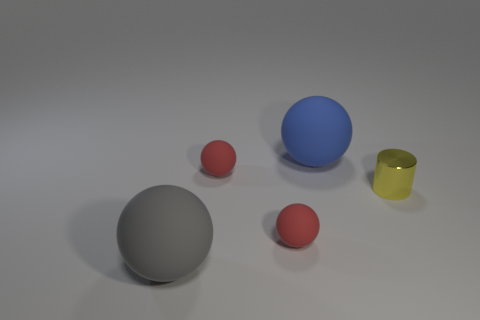Are there any other tiny yellow cylinders made of the same material as the cylinder?
Provide a succinct answer. No. The metallic cylinder has what size?
Your answer should be compact. Small. How many cyan things are either small rubber objects or shiny cylinders?
Give a very brief answer. 0. How many small red matte things have the same shape as the gray rubber thing?
Offer a terse response. 2. What number of matte objects have the same size as the yellow metallic cylinder?
Make the answer very short. 2. There is another big object that is the same shape as the large blue object; what is it made of?
Provide a succinct answer. Rubber. There is a large ball that is behind the big gray sphere; what color is it?
Your answer should be compact. Blue. Is the number of small things that are to the right of the large blue ball greater than the number of brown matte objects?
Offer a very short reply. Yes. What is the color of the small metal cylinder?
Your answer should be compact. Yellow. What shape is the large thing that is in front of the large matte sphere to the right of the big matte object that is in front of the blue rubber thing?
Offer a terse response. Sphere. 